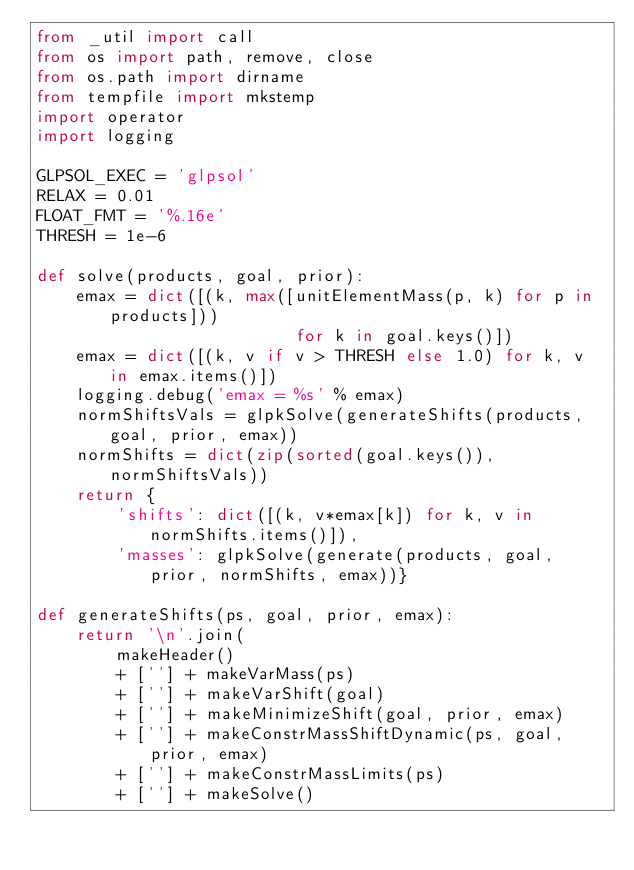Convert code to text. <code><loc_0><loc_0><loc_500><loc_500><_Python_>from _util import call
from os import path, remove, close
from os.path import dirname
from tempfile import mkstemp
import operator
import logging

GLPSOL_EXEC = 'glpsol'
RELAX = 0.01
FLOAT_FMT = '%.16e'
THRESH = 1e-6

def solve(products, goal, prior):
    emax = dict([(k, max([unitElementMass(p, k) for p in products]))
                          for k in goal.keys()])
    emax = dict([(k, v if v > THRESH else 1.0) for k, v in emax.items()])
    logging.debug('emax = %s' % emax)
    normShiftsVals = glpkSolve(generateShifts(products, goal, prior, emax))
    normShifts = dict(zip(sorted(goal.keys()), normShiftsVals))
    return {
        'shifts': dict([(k, v*emax[k]) for k, v in normShifts.items()]),
        'masses': glpkSolve(generate(products, goal, prior, normShifts, emax))}

def generateShifts(ps, goal, prior, emax):
    return '\n'.join(
        makeHeader()
        + [''] + makeVarMass(ps)
        + [''] + makeVarShift(goal)
        + [''] + makeMinimizeShift(goal, prior, emax)
        + [''] + makeConstrMassShiftDynamic(ps, goal, prior, emax)
        + [''] + makeConstrMassLimits(ps)
        + [''] + makeSolve()</code> 